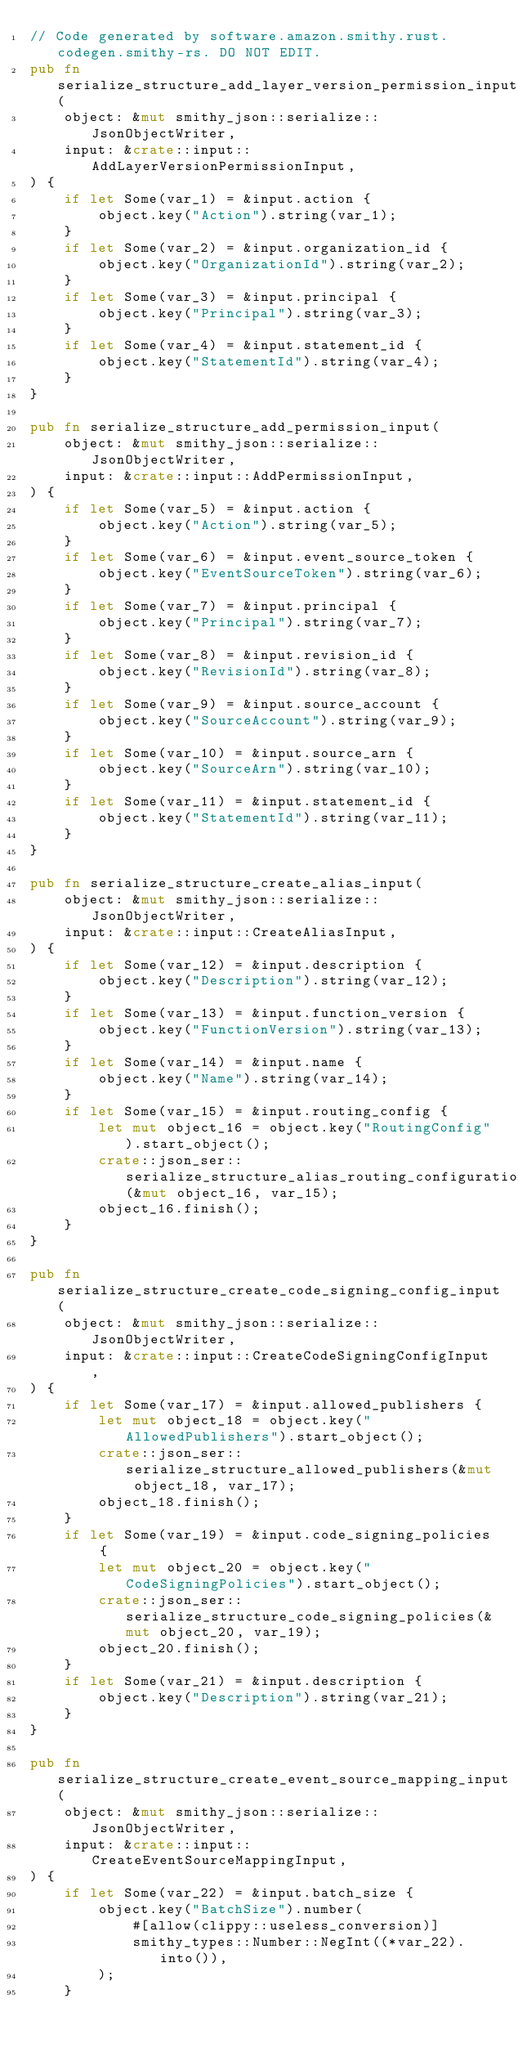Convert code to text. <code><loc_0><loc_0><loc_500><loc_500><_Rust_>// Code generated by software.amazon.smithy.rust.codegen.smithy-rs. DO NOT EDIT.
pub fn serialize_structure_add_layer_version_permission_input(
    object: &mut smithy_json::serialize::JsonObjectWriter,
    input: &crate::input::AddLayerVersionPermissionInput,
) {
    if let Some(var_1) = &input.action {
        object.key("Action").string(var_1);
    }
    if let Some(var_2) = &input.organization_id {
        object.key("OrganizationId").string(var_2);
    }
    if let Some(var_3) = &input.principal {
        object.key("Principal").string(var_3);
    }
    if let Some(var_4) = &input.statement_id {
        object.key("StatementId").string(var_4);
    }
}

pub fn serialize_structure_add_permission_input(
    object: &mut smithy_json::serialize::JsonObjectWriter,
    input: &crate::input::AddPermissionInput,
) {
    if let Some(var_5) = &input.action {
        object.key("Action").string(var_5);
    }
    if let Some(var_6) = &input.event_source_token {
        object.key("EventSourceToken").string(var_6);
    }
    if let Some(var_7) = &input.principal {
        object.key("Principal").string(var_7);
    }
    if let Some(var_8) = &input.revision_id {
        object.key("RevisionId").string(var_8);
    }
    if let Some(var_9) = &input.source_account {
        object.key("SourceAccount").string(var_9);
    }
    if let Some(var_10) = &input.source_arn {
        object.key("SourceArn").string(var_10);
    }
    if let Some(var_11) = &input.statement_id {
        object.key("StatementId").string(var_11);
    }
}

pub fn serialize_structure_create_alias_input(
    object: &mut smithy_json::serialize::JsonObjectWriter,
    input: &crate::input::CreateAliasInput,
) {
    if let Some(var_12) = &input.description {
        object.key("Description").string(var_12);
    }
    if let Some(var_13) = &input.function_version {
        object.key("FunctionVersion").string(var_13);
    }
    if let Some(var_14) = &input.name {
        object.key("Name").string(var_14);
    }
    if let Some(var_15) = &input.routing_config {
        let mut object_16 = object.key("RoutingConfig").start_object();
        crate::json_ser::serialize_structure_alias_routing_configuration(&mut object_16, var_15);
        object_16.finish();
    }
}

pub fn serialize_structure_create_code_signing_config_input(
    object: &mut smithy_json::serialize::JsonObjectWriter,
    input: &crate::input::CreateCodeSigningConfigInput,
) {
    if let Some(var_17) = &input.allowed_publishers {
        let mut object_18 = object.key("AllowedPublishers").start_object();
        crate::json_ser::serialize_structure_allowed_publishers(&mut object_18, var_17);
        object_18.finish();
    }
    if let Some(var_19) = &input.code_signing_policies {
        let mut object_20 = object.key("CodeSigningPolicies").start_object();
        crate::json_ser::serialize_structure_code_signing_policies(&mut object_20, var_19);
        object_20.finish();
    }
    if let Some(var_21) = &input.description {
        object.key("Description").string(var_21);
    }
}

pub fn serialize_structure_create_event_source_mapping_input(
    object: &mut smithy_json::serialize::JsonObjectWriter,
    input: &crate::input::CreateEventSourceMappingInput,
) {
    if let Some(var_22) = &input.batch_size {
        object.key("BatchSize").number(
            #[allow(clippy::useless_conversion)]
            smithy_types::Number::NegInt((*var_22).into()),
        );
    }</code> 